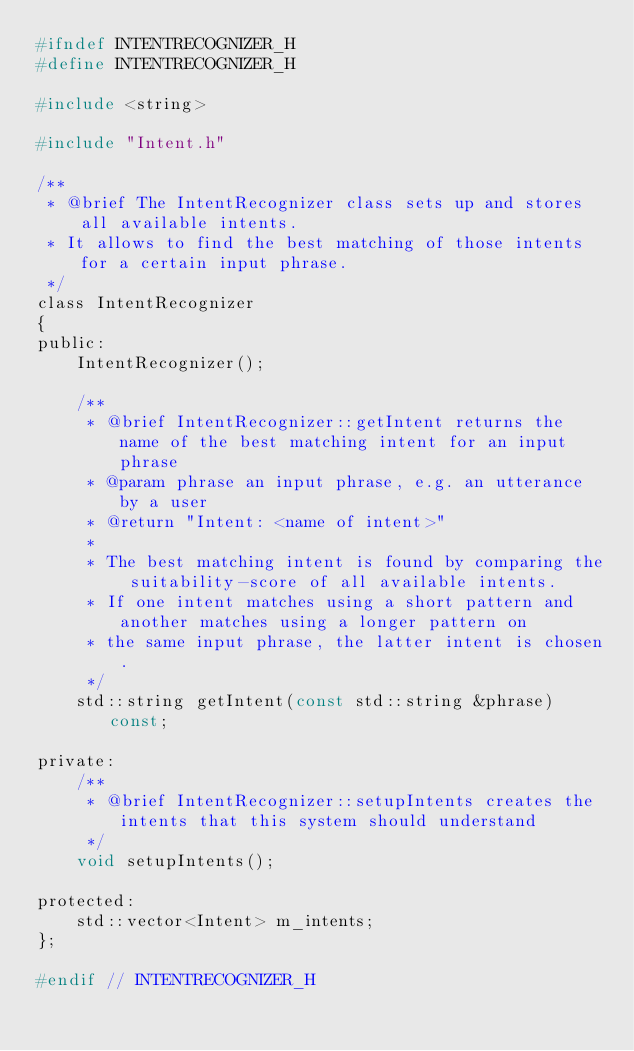Convert code to text. <code><loc_0><loc_0><loc_500><loc_500><_C_>#ifndef INTENTRECOGNIZER_H
#define INTENTRECOGNIZER_H

#include <string>

#include "Intent.h"

/**
 * @brief The IntentRecognizer class sets up and stores all available intents.
 * It allows to find the best matching of those intents for a certain input phrase.
 */
class IntentRecognizer
{
public:
    IntentRecognizer();

    /**
     * @brief IntentRecognizer::getIntent returns the name of the best matching intent for an input phrase
     * @param phrase an input phrase, e.g. an utterance by a user
     * @return "Intent: <name of intent>"
     *
     * The best matching intent is found by comparing the suitability-score of all available intents.
     * If one intent matches using a short pattern and another matches using a longer pattern on
     * the same input phrase, the latter intent is chosen.
     */
    std::string getIntent(const std::string &phrase) const;

private:
    /**
     * @brief IntentRecognizer::setupIntents creates the intents that this system should understand
     */
    void setupIntents();

protected:
    std::vector<Intent> m_intents;
};

#endif // INTENTRECOGNIZER_H
</code> 